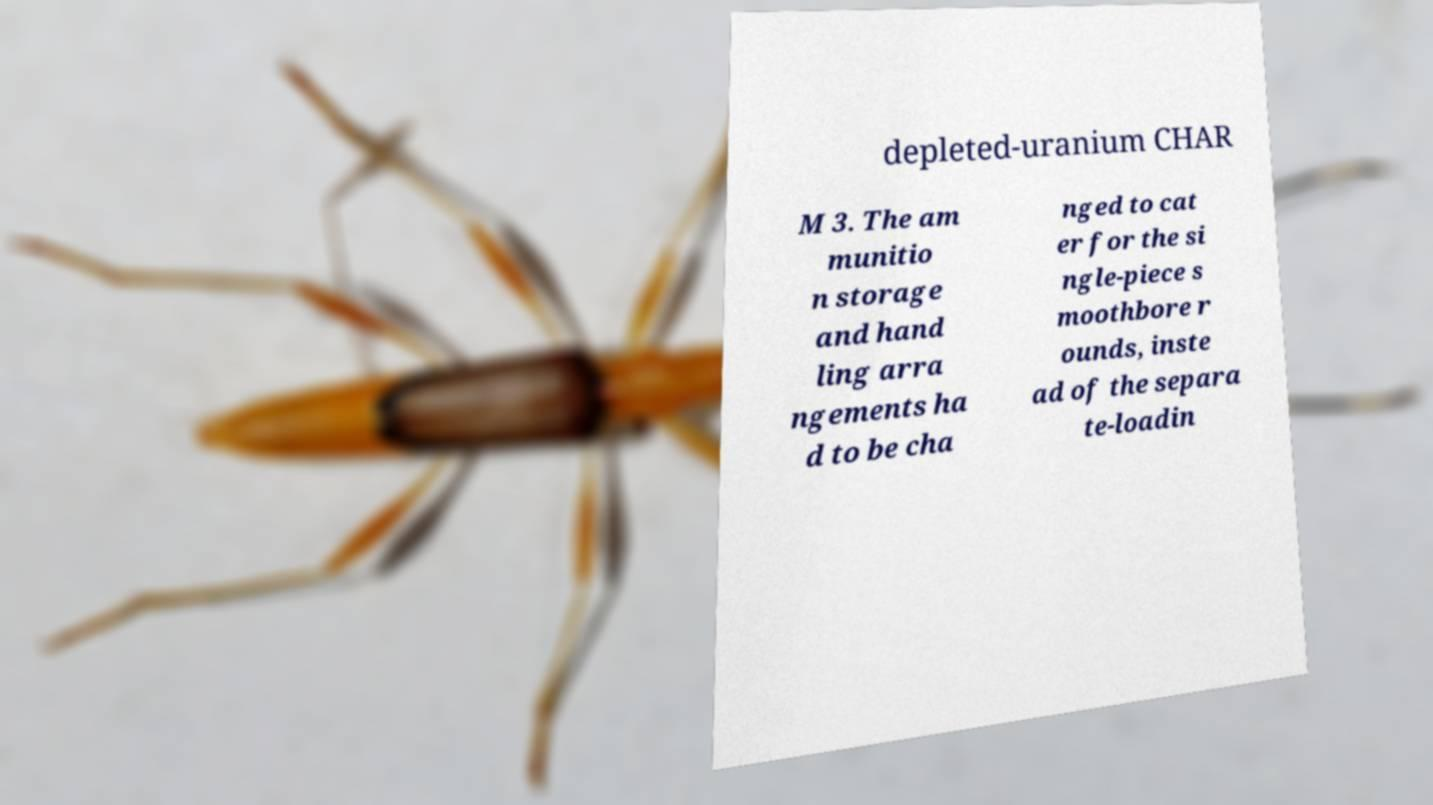Can you accurately transcribe the text from the provided image for me? depleted-uranium CHAR M 3. The am munitio n storage and hand ling arra ngements ha d to be cha nged to cat er for the si ngle-piece s moothbore r ounds, inste ad of the separa te-loadin 